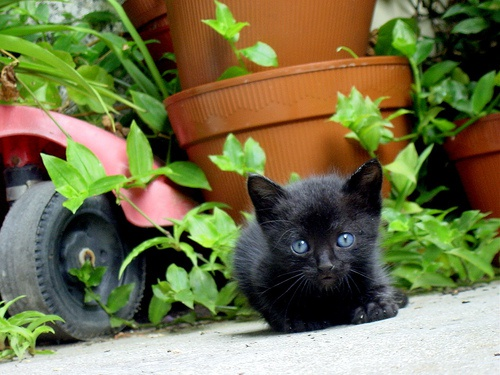Describe the objects in this image and their specific colors. I can see motorcycle in green, black, gray, darkgray, and lightpink tones, potted plant in green, brown, maroon, orange, and lightgreen tones, cat in green, black, gray, and darkblue tones, potted plant in green, brown, maroon, olive, and lightgreen tones, and potted plant in green, maroon, darkgreen, and black tones in this image. 